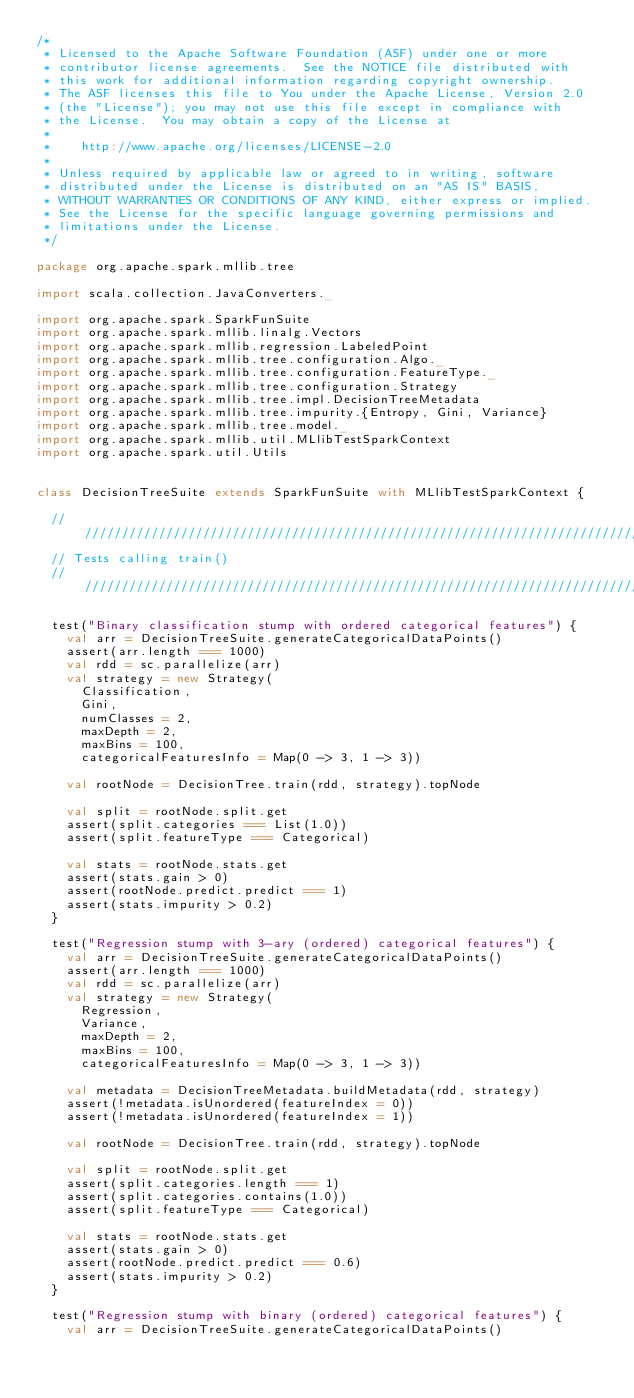<code> <loc_0><loc_0><loc_500><loc_500><_Scala_>/*
 * Licensed to the Apache Software Foundation (ASF) under one or more
 * contributor license agreements.  See the NOTICE file distributed with
 * this work for additional information regarding copyright ownership.
 * The ASF licenses this file to You under the Apache License, Version 2.0
 * (the "License"); you may not use this file except in compliance with
 * the License.  You may obtain a copy of the License at
 *
 *    http://www.apache.org/licenses/LICENSE-2.0
 *
 * Unless required by applicable law or agreed to in writing, software
 * distributed under the License is distributed on an "AS IS" BASIS,
 * WITHOUT WARRANTIES OR CONDITIONS OF ANY KIND, either express or implied.
 * See the License for the specific language governing permissions and
 * limitations under the License.
 */

package org.apache.spark.mllib.tree

import scala.collection.JavaConverters._

import org.apache.spark.SparkFunSuite
import org.apache.spark.mllib.linalg.Vectors
import org.apache.spark.mllib.regression.LabeledPoint
import org.apache.spark.mllib.tree.configuration.Algo._
import org.apache.spark.mllib.tree.configuration.FeatureType._
import org.apache.spark.mllib.tree.configuration.Strategy
import org.apache.spark.mllib.tree.impl.DecisionTreeMetadata
import org.apache.spark.mllib.tree.impurity.{Entropy, Gini, Variance}
import org.apache.spark.mllib.tree.model._
import org.apache.spark.mllib.util.MLlibTestSparkContext
import org.apache.spark.util.Utils


class DecisionTreeSuite extends SparkFunSuite with MLlibTestSparkContext {

  /////////////////////////////////////////////////////////////////////////////
  // Tests calling train()
  /////////////////////////////////////////////////////////////////////////////

  test("Binary classification stump with ordered categorical features") {
    val arr = DecisionTreeSuite.generateCategoricalDataPoints()
    assert(arr.length === 1000)
    val rdd = sc.parallelize(arr)
    val strategy = new Strategy(
      Classification,
      Gini,
      numClasses = 2,
      maxDepth = 2,
      maxBins = 100,
      categoricalFeaturesInfo = Map(0 -> 3, 1 -> 3))

    val rootNode = DecisionTree.train(rdd, strategy).topNode

    val split = rootNode.split.get
    assert(split.categories === List(1.0))
    assert(split.featureType === Categorical)

    val stats = rootNode.stats.get
    assert(stats.gain > 0)
    assert(rootNode.predict.predict === 1)
    assert(stats.impurity > 0.2)
  }

  test("Regression stump with 3-ary (ordered) categorical features") {
    val arr = DecisionTreeSuite.generateCategoricalDataPoints()
    assert(arr.length === 1000)
    val rdd = sc.parallelize(arr)
    val strategy = new Strategy(
      Regression,
      Variance,
      maxDepth = 2,
      maxBins = 100,
      categoricalFeaturesInfo = Map(0 -> 3, 1 -> 3))

    val metadata = DecisionTreeMetadata.buildMetadata(rdd, strategy)
    assert(!metadata.isUnordered(featureIndex = 0))
    assert(!metadata.isUnordered(featureIndex = 1))

    val rootNode = DecisionTree.train(rdd, strategy).topNode

    val split = rootNode.split.get
    assert(split.categories.length === 1)
    assert(split.categories.contains(1.0))
    assert(split.featureType === Categorical)

    val stats = rootNode.stats.get
    assert(stats.gain > 0)
    assert(rootNode.predict.predict === 0.6)
    assert(stats.impurity > 0.2)
  }

  test("Regression stump with binary (ordered) categorical features") {
    val arr = DecisionTreeSuite.generateCategoricalDataPoints()</code> 